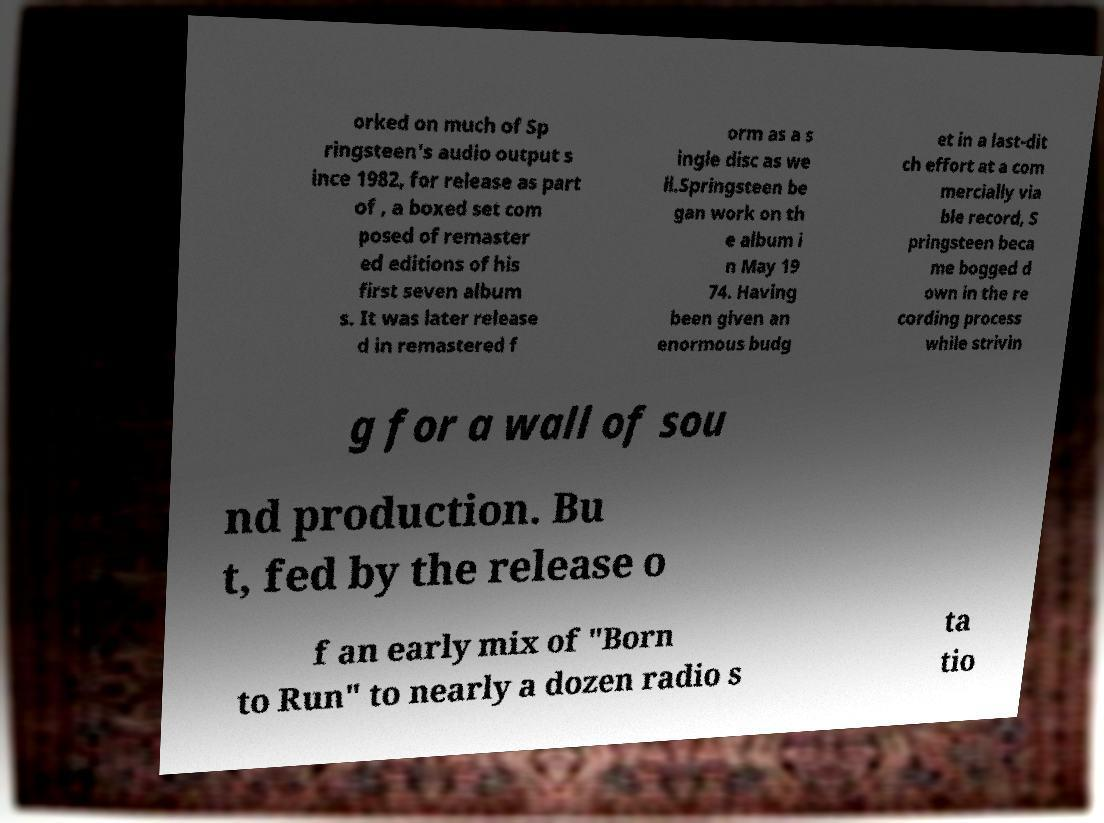Could you assist in decoding the text presented in this image and type it out clearly? orked on much of Sp ringsteen's audio output s ince 1982, for release as part of , a boxed set com posed of remaster ed editions of his first seven album s. It was later release d in remastered f orm as a s ingle disc as we ll.Springsteen be gan work on th e album i n May 19 74. Having been given an enormous budg et in a last-dit ch effort at a com mercially via ble record, S pringsteen beca me bogged d own in the re cording process while strivin g for a wall of sou nd production. Bu t, fed by the release o f an early mix of "Born to Run" to nearly a dozen radio s ta tio 